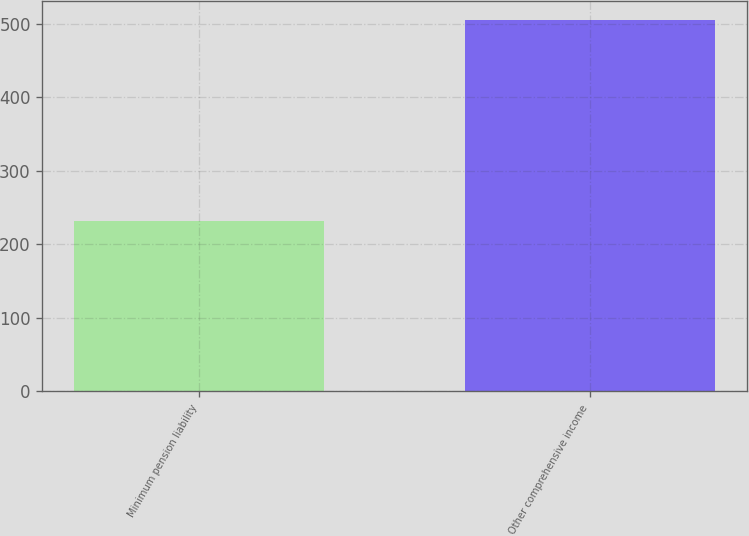Convert chart. <chart><loc_0><loc_0><loc_500><loc_500><bar_chart><fcel>Minimum pension liability<fcel>Other comprehensive income<nl><fcel>231.8<fcel>505.4<nl></chart> 